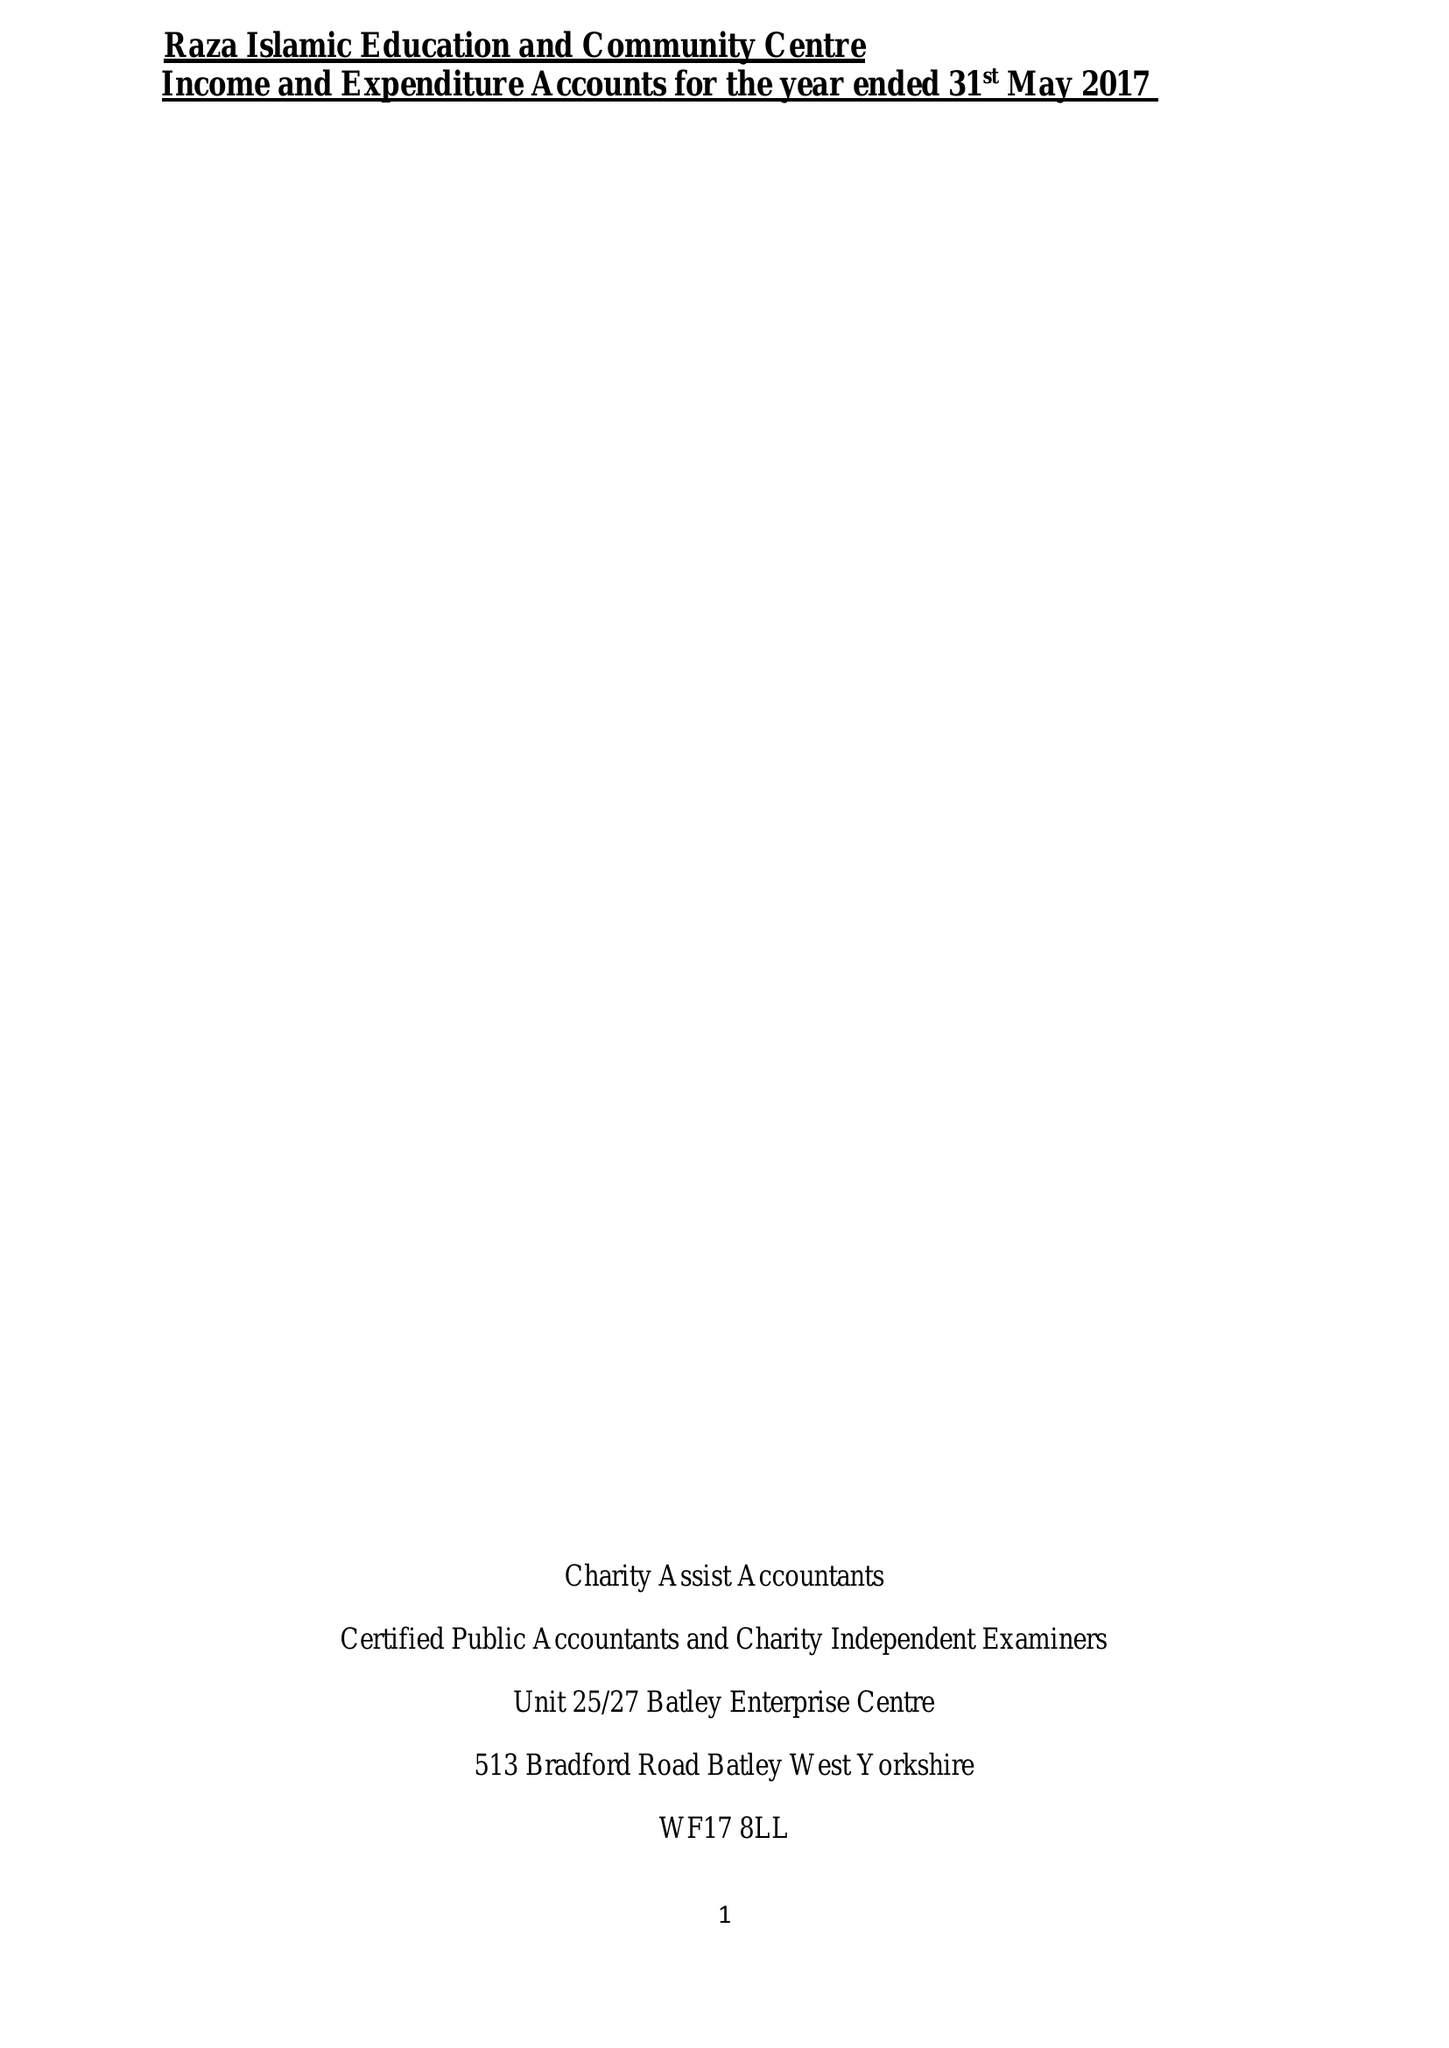What is the value for the charity_number?
Answer the question using a single word or phrase. 1147125 